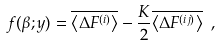<formula> <loc_0><loc_0><loc_500><loc_500>f ( \beta ; y ) = \overline { \left \langle \Delta F ^ { ( i ) } \right \rangle } - \frac { K } { 2 } \overline { \left \langle \Delta F ^ { ( i j ) } \right \rangle } \ ,</formula> 